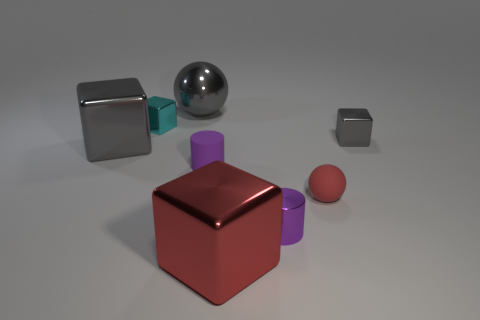How many other objects are there of the same size as the purple matte object?
Your response must be concise. 4. There is a gray metallic thing that is left of the big sphere; what is its size?
Give a very brief answer. Large. Are there any other things that are the same color as the small metal cylinder?
Ensure brevity in your answer.  Yes. Are the gray thing right of the red shiny object and the big red thing made of the same material?
Provide a short and direct response. Yes. What number of cubes are behind the tiny sphere and left of the small sphere?
Offer a terse response. 2. What size is the gray cube right of the big gray metallic object that is behind the big gray shiny block?
Your answer should be compact. Small. Are there any other things that have the same material as the small red object?
Offer a very short reply. Yes. Is the number of tiny cyan objects greater than the number of cylinders?
Give a very brief answer. No. Does the big thing that is behind the cyan metallic block have the same color as the large shiny object that is in front of the big gray block?
Give a very brief answer. No. There is a big gray metal object that is in front of the small gray block; is there a metal block that is behind it?
Keep it short and to the point. Yes. 